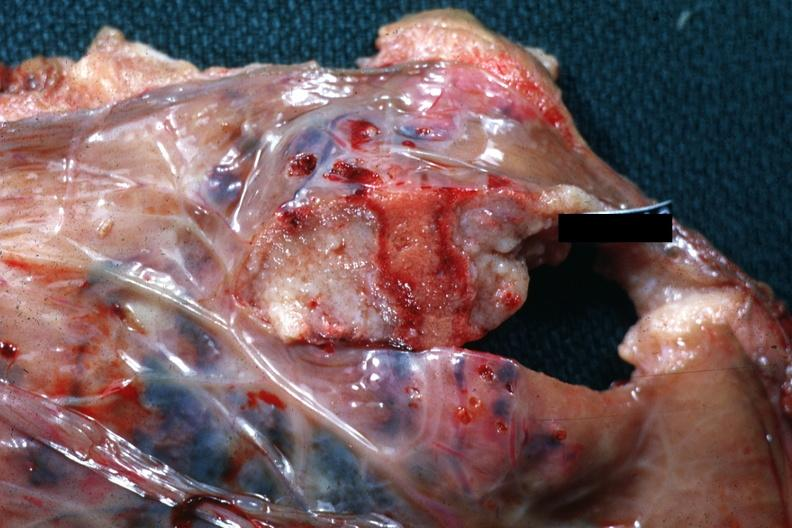s female reproductive present?
Answer the question using a single word or phrase. Yes 